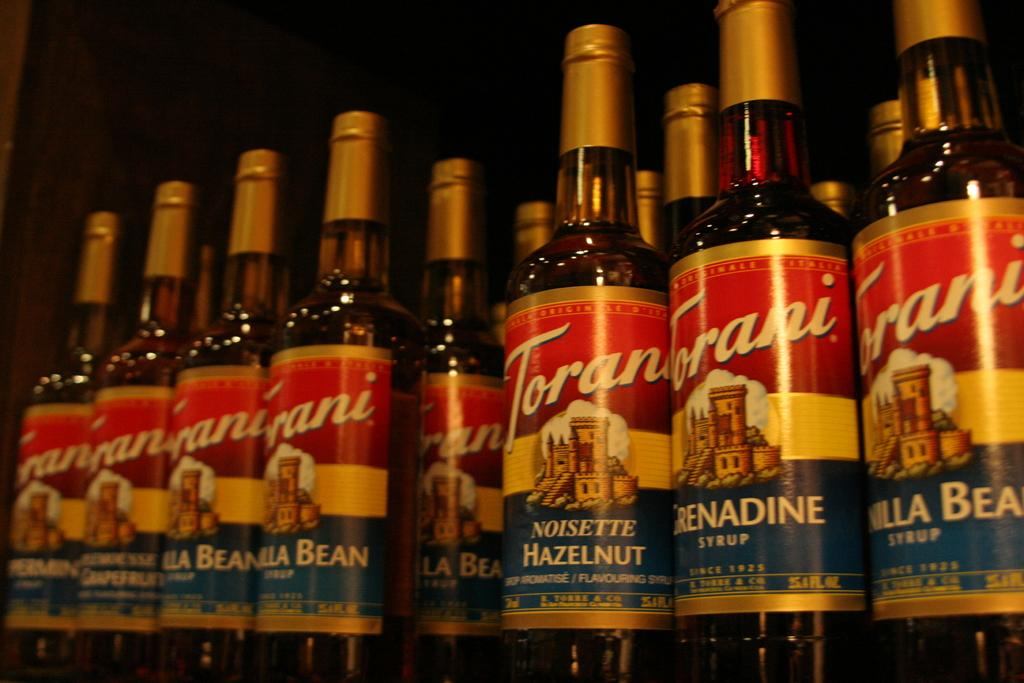<image>
Describe the image concisely. Bottles of Torani flavoring are lined up on a shelf. 